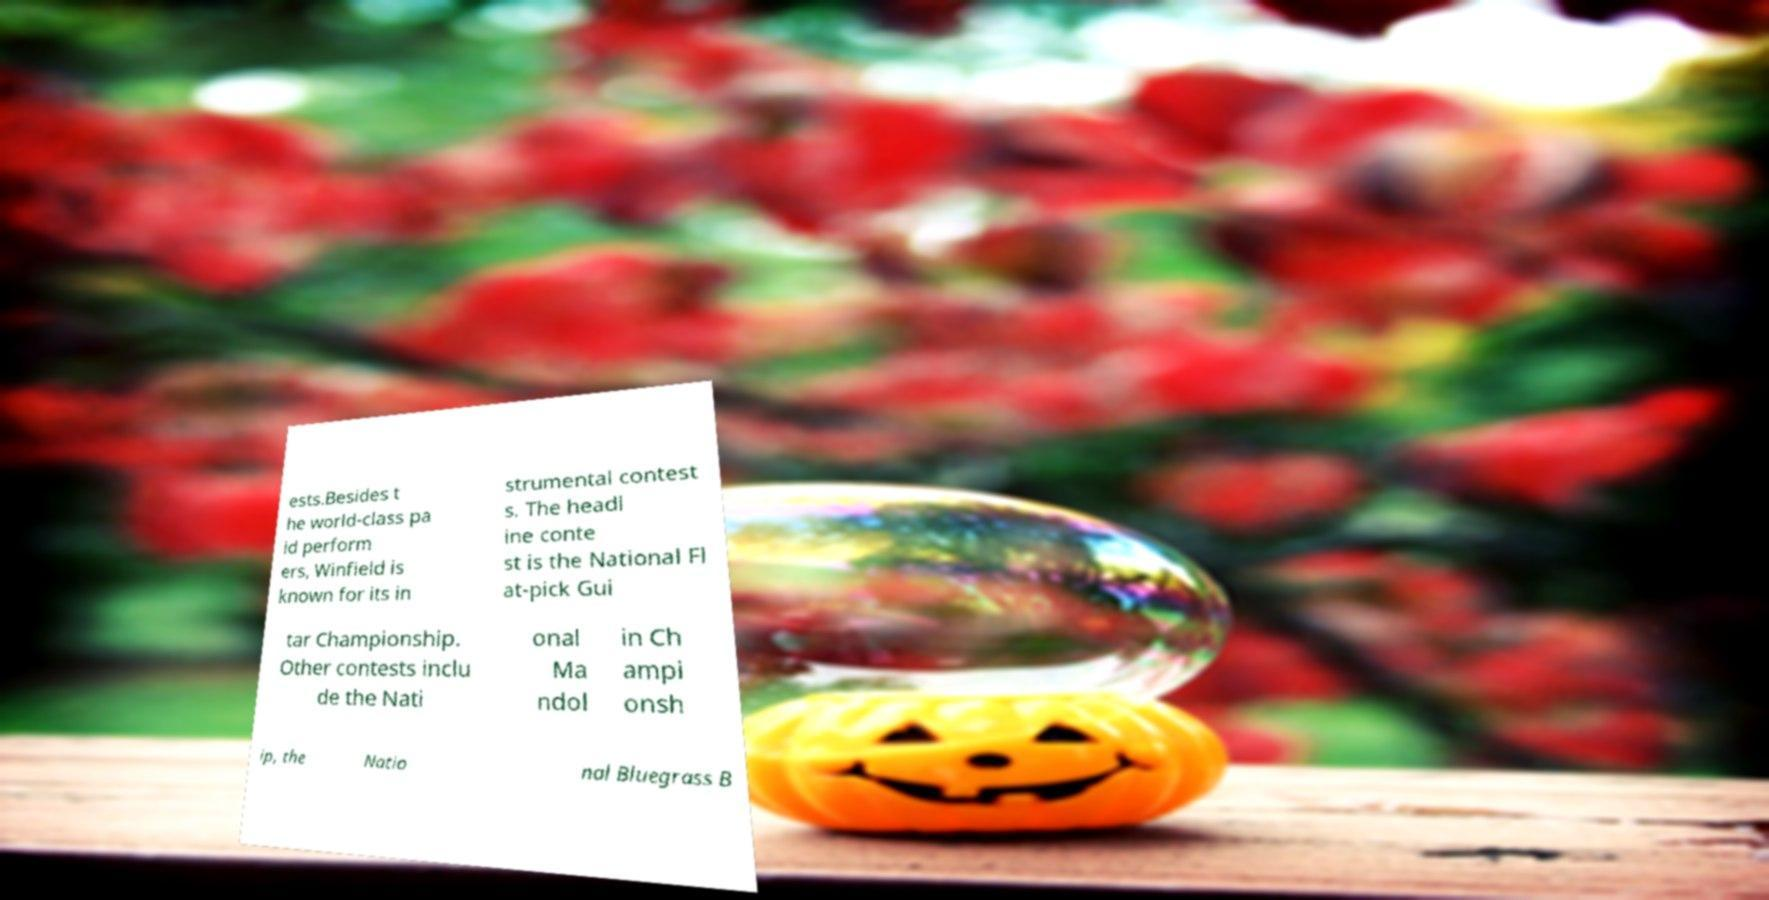What messages or text are displayed in this image? I need them in a readable, typed format. ests.Besides t he world-class pa id perform ers, Winfield is known for its in strumental contest s. The headl ine conte st is the National Fl at-pick Gui tar Championship. Other contests inclu de the Nati onal Ma ndol in Ch ampi onsh ip, the Natio nal Bluegrass B 